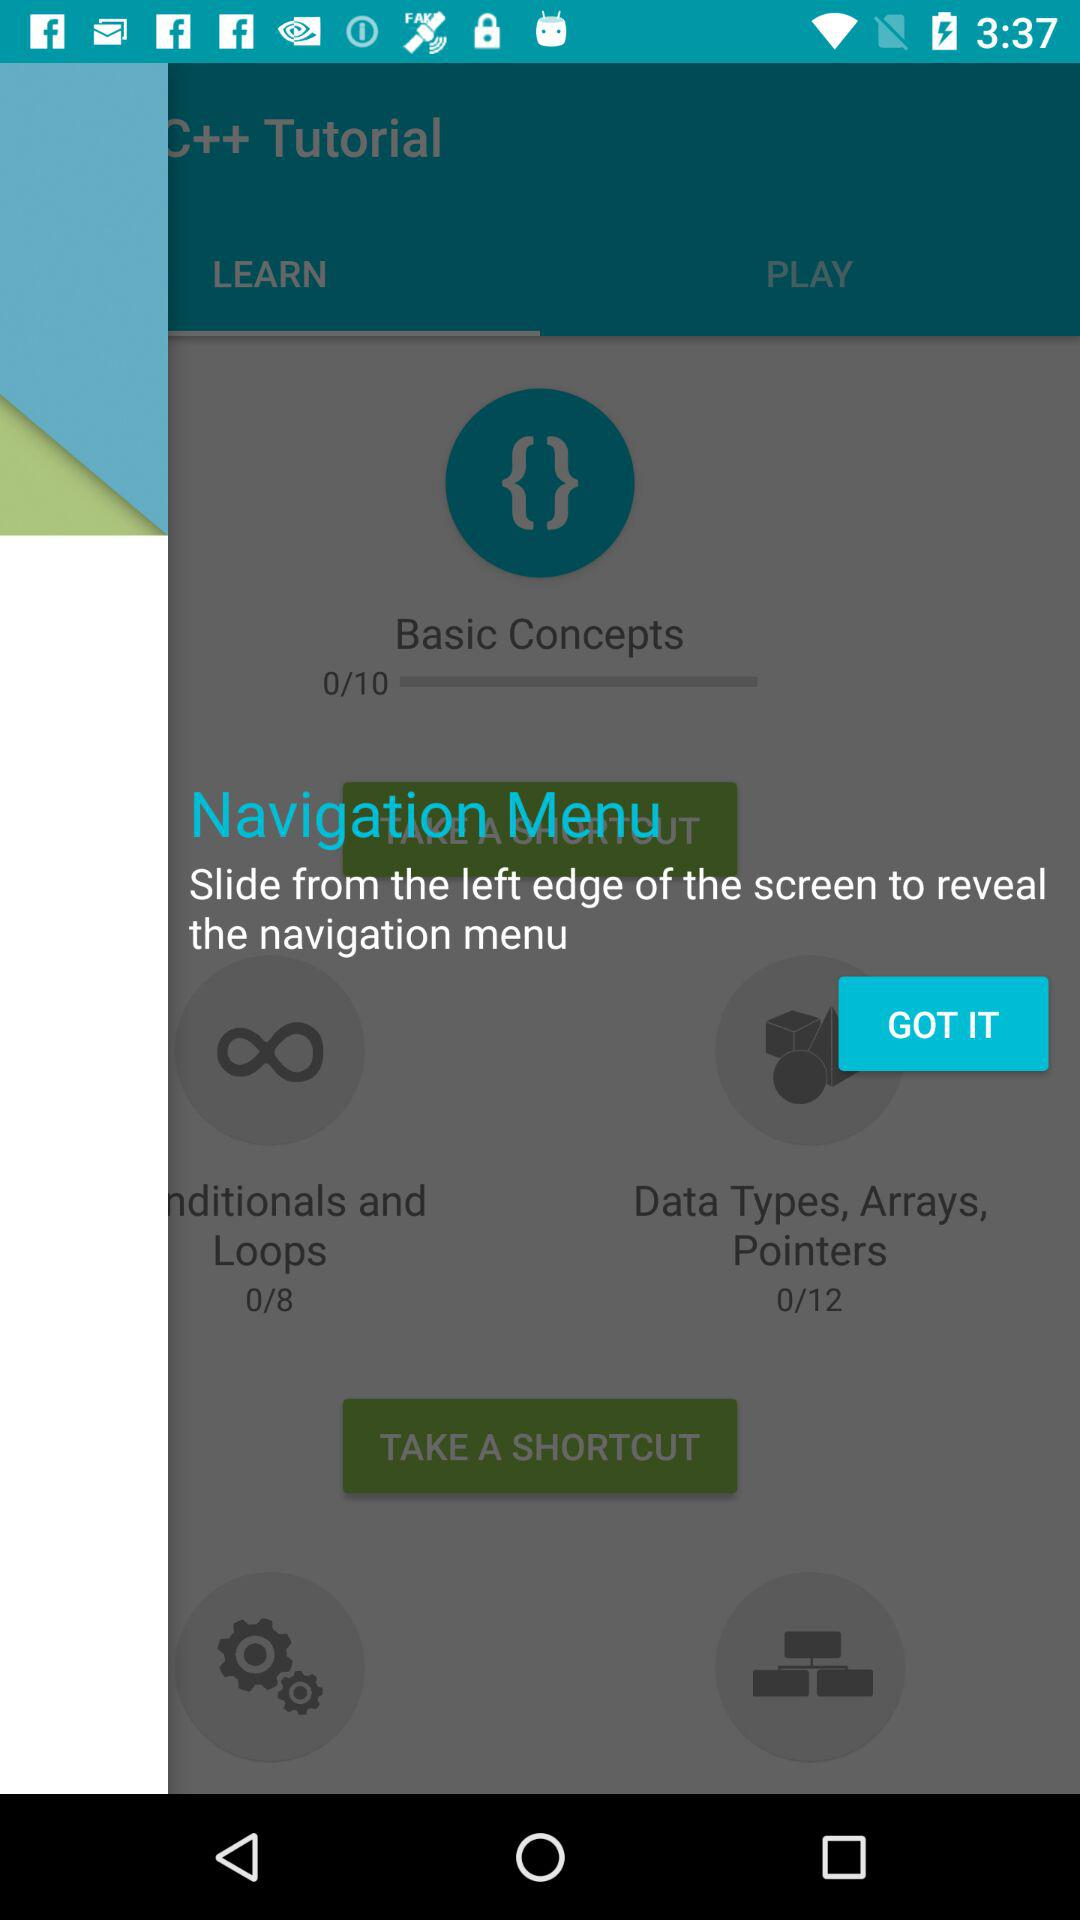What is the total number of modules in "Data Types, Arrays, Pointers"? The total number of modules in "Data Types, Arrays, Pointers" is 12. 